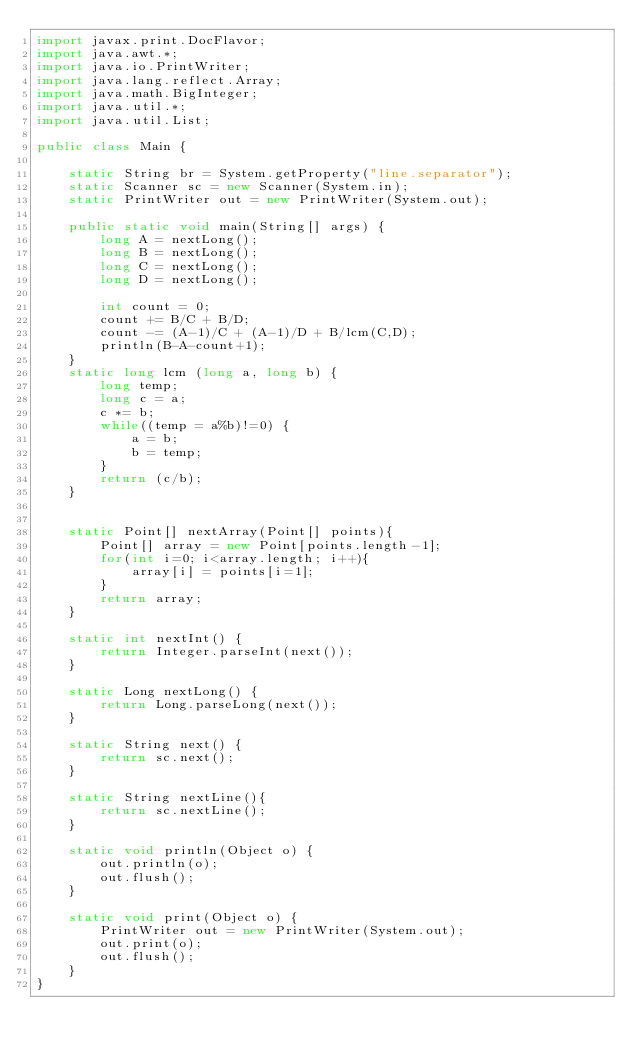Convert code to text. <code><loc_0><loc_0><loc_500><loc_500><_Java_>import javax.print.DocFlavor;
import java.awt.*;
import java.io.PrintWriter;
import java.lang.reflect.Array;
import java.math.BigInteger;
import java.util.*;
import java.util.List;

public class Main {

    static String br = System.getProperty("line.separator");
    static Scanner sc = new Scanner(System.in);
    static PrintWriter out = new PrintWriter(System.out);

    public static void main(String[] args) {
        long A = nextLong();
        long B = nextLong();
        long C = nextLong();
        long D = nextLong();

        int count = 0;
        count += B/C + B/D;
        count -= (A-1)/C + (A-1)/D + B/lcm(C,D);
        println(B-A-count+1);
    }
    static long lcm (long a, long b) {
        long temp;
        long c = a;
        c *= b;
        while((temp = a%b)!=0) {
            a = b;
            b = temp;
        }
        return (c/b);
    }


    static Point[] nextArray(Point[] points){
        Point[] array = new Point[points.length-1];
        for(int i=0; i<array.length; i++){
            array[i] = points[i=1];
        }
        return array;
    }

    static int nextInt() {
        return Integer.parseInt(next());
    }

    static Long nextLong() {
        return Long.parseLong(next());
    }

    static String next() {
        return sc.next();
    }

    static String nextLine(){
        return sc.nextLine();
    }

    static void println(Object o) {
        out.println(o);
        out.flush();
    }

    static void print(Object o) {
        PrintWriter out = new PrintWriter(System.out);
        out.print(o);
        out.flush();
    }
}
</code> 